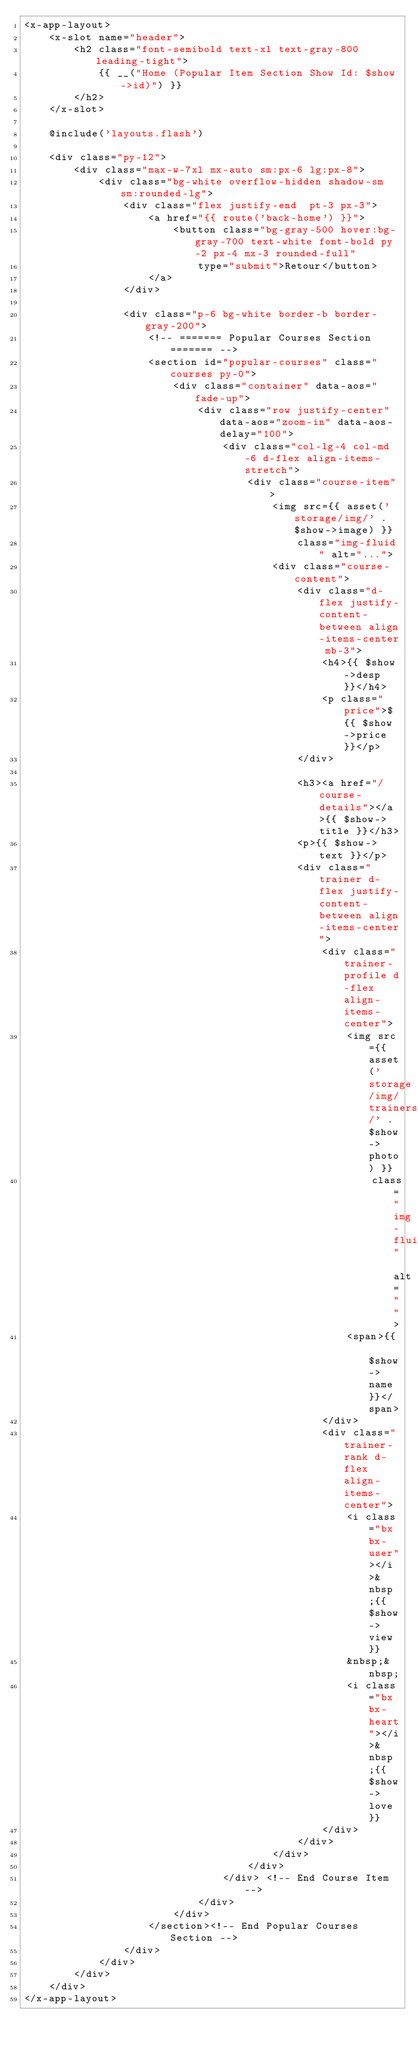<code> <loc_0><loc_0><loc_500><loc_500><_PHP_><x-app-layout>
    <x-slot name="header">
        <h2 class="font-semibold text-xl text-gray-800 leading-tight">
            {{ __("Home (Popular Item Section Show Id: $show->id)") }}
        </h2>
    </x-slot>

    @include('layouts.flash')

    <div class="py-12">
        <div class="max-w-7xl mx-auto sm:px-6 lg:px-8">
            <div class="bg-white overflow-hidden shadow-sm sm:rounded-lg">
                <div class="flex justify-end  pt-3 px-3">
                    <a href="{{ route('back-home') }}">
                        <button class="bg-gray-500 hover:bg-gray-700 text-white font-bold py-2 px-4 mx-3 rounded-full"
                            type="submit">Retour</button>
                    </a>
                </div>

                <div class="p-6 bg-white border-b border-gray-200">
                    <!-- ======= Popular Courses Section ======= -->
                    <section id="popular-courses" class="courses py-0">
                        <div class="container" data-aos="fade-up">
                            <div class="row justify-center" data-aos="zoom-in" data-aos-delay="100">
                                <div class="col-lg-4 col-md-6 d-flex align-items-stretch">
                                    <div class="course-item">
                                        <img src={{ asset('storage/img/' . $show->image) }}
                                            class="img-fluid" alt="...">
                                        <div class="course-content">
                                            <div class="d-flex justify-content-between align-items-center mb-3">
                                                <h4>{{ $show->desp }}</h4>
                                                <p class="price">${{ $show->price }}</p>
                                            </div>

                                            <h3><a href="/course-details"></a>{{ $show->title }}</h3>
                                            <p>{{ $show->text }}</p>
                                            <div class="trainer d-flex justify-content-between align-items-center">
                                                <div class="trainer-profile d-flex align-items-center">
                                                    <img src={{ asset('storage/img/trainers/' . $show->photo) }}
                                                        class="img-fluid" alt="">
                                                    <span>{{ $show->name }}</span>
                                                </div>
                                                <div class="trainer-rank d-flex align-items-center">
                                                    <i class="bx bx-user"></i>&nbsp;{{ $show->view }}
                                                    &nbsp;&nbsp;
                                                    <i class="bx bx-heart"></i>&nbsp;{{ $show->love }}
                                                </div>
                                            </div>
                                        </div>
                                    </div>
                                </div> <!-- End Course Item-->
                            </div>
                        </div>
                    </section><!-- End Popular Courses Section -->
                </div>
            </div>
        </div>
    </div>
</x-app-layout>
</code> 